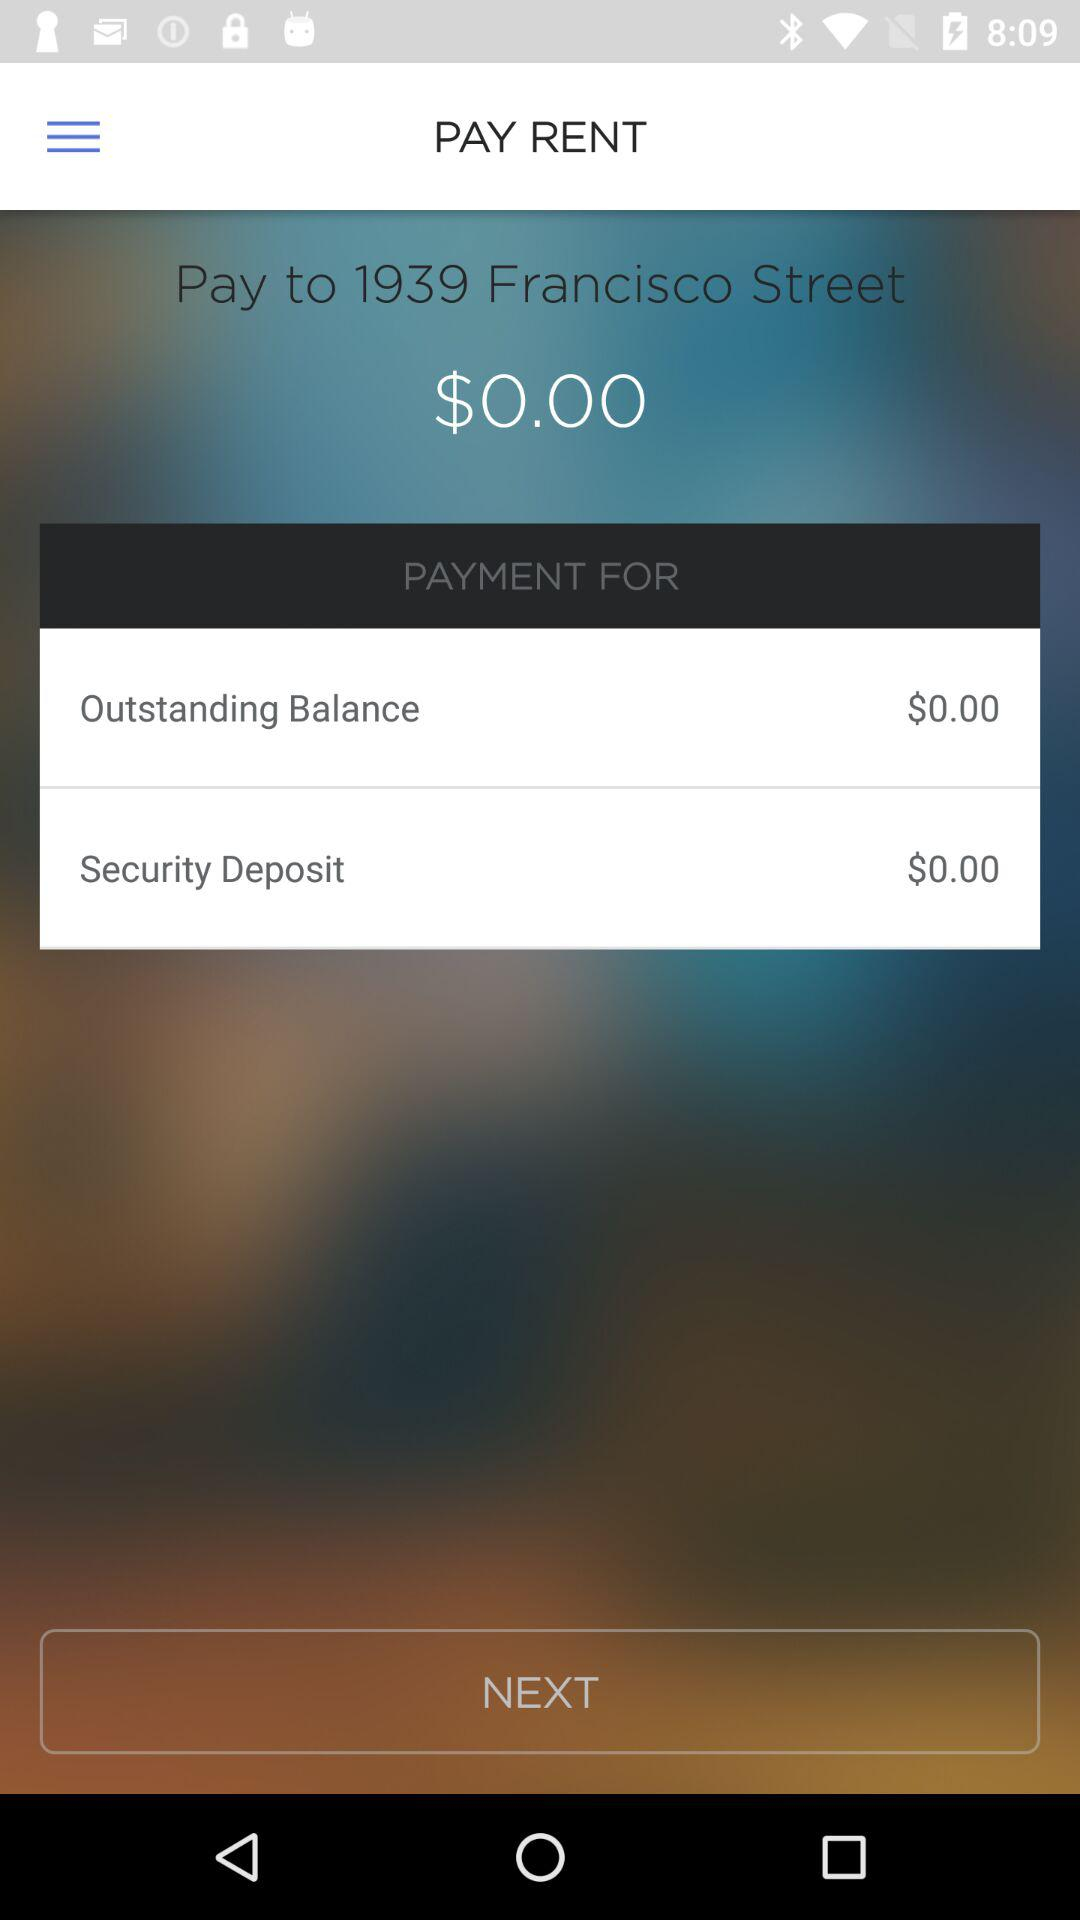What is the mentioned location? The mentioned location is 1939 Francisco Street. 